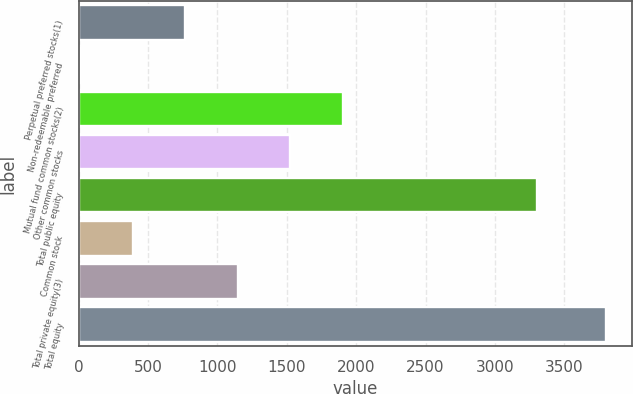<chart> <loc_0><loc_0><loc_500><loc_500><bar_chart><fcel>Perpetual preferred stocks(1)<fcel>Non-redeemable preferred<fcel>Mutual fund common stocks(2)<fcel>Other common stocks<fcel>Total public equity<fcel>Common stock<fcel>Total private equity(3)<fcel>Total equity<nl><fcel>769.2<fcel>12<fcel>1905<fcel>1526.4<fcel>3302<fcel>390.6<fcel>1147.8<fcel>3798<nl></chart> 